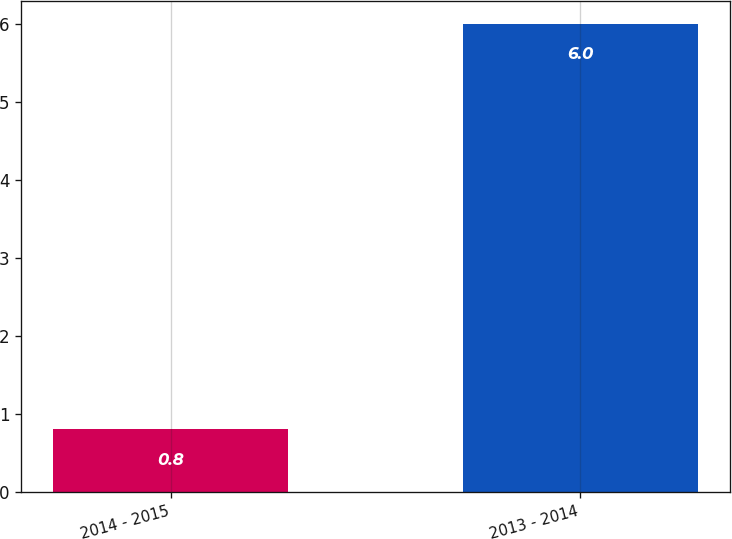<chart> <loc_0><loc_0><loc_500><loc_500><bar_chart><fcel>2014 - 2015<fcel>2013 - 2014<nl><fcel>0.8<fcel>6<nl></chart> 